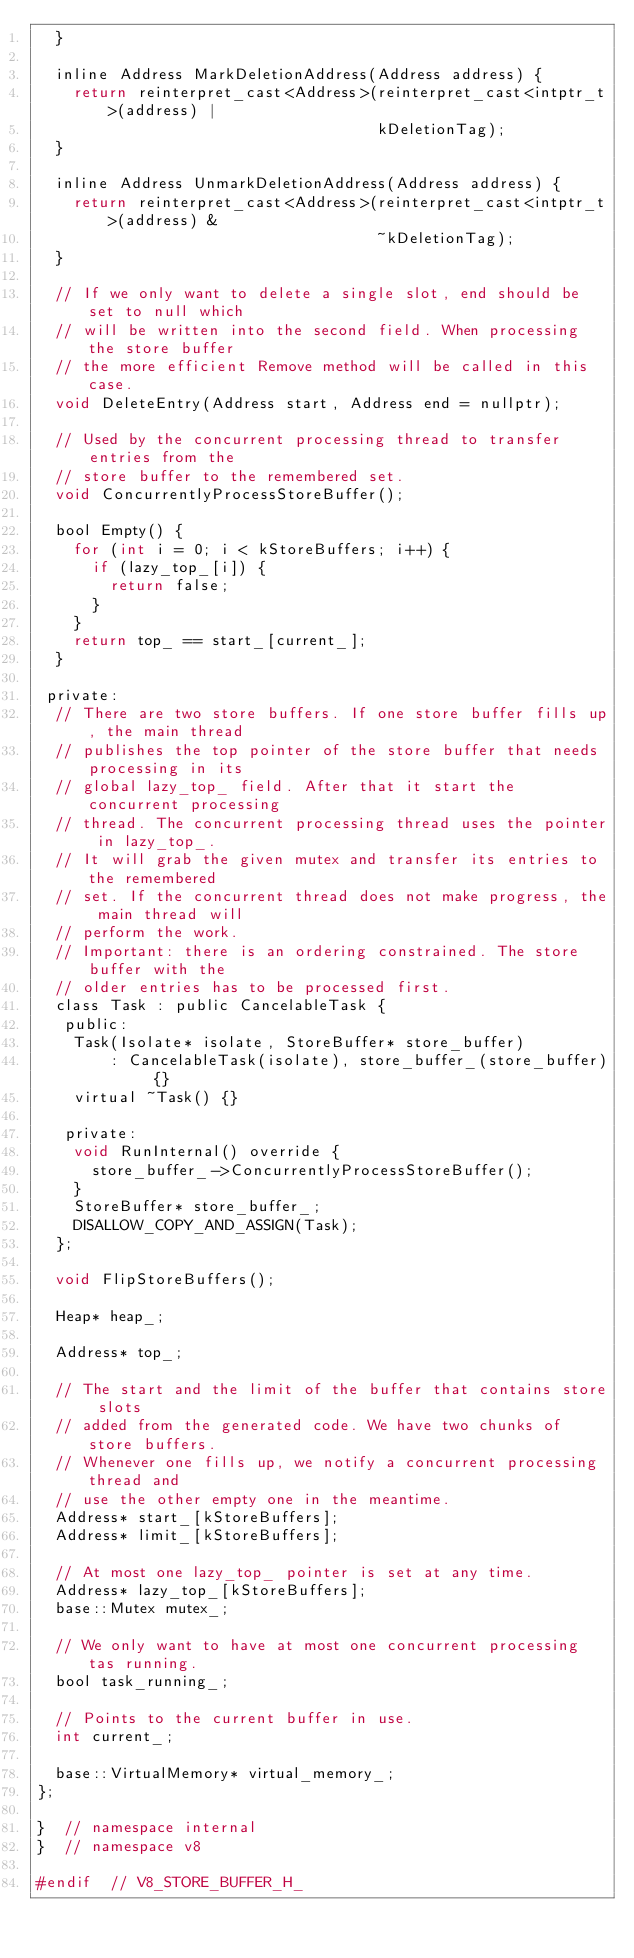<code> <loc_0><loc_0><loc_500><loc_500><_C_>  }

  inline Address MarkDeletionAddress(Address address) {
    return reinterpret_cast<Address>(reinterpret_cast<intptr_t>(address) |
                                     kDeletionTag);
  }

  inline Address UnmarkDeletionAddress(Address address) {
    return reinterpret_cast<Address>(reinterpret_cast<intptr_t>(address) &
                                     ~kDeletionTag);
  }

  // If we only want to delete a single slot, end should be set to null which
  // will be written into the second field. When processing the store buffer
  // the more efficient Remove method will be called in this case.
  void DeleteEntry(Address start, Address end = nullptr);

  // Used by the concurrent processing thread to transfer entries from the
  // store buffer to the remembered set.
  void ConcurrentlyProcessStoreBuffer();

  bool Empty() {
    for (int i = 0; i < kStoreBuffers; i++) {
      if (lazy_top_[i]) {
        return false;
      }
    }
    return top_ == start_[current_];
  }

 private:
  // There are two store buffers. If one store buffer fills up, the main thread
  // publishes the top pointer of the store buffer that needs processing in its
  // global lazy_top_ field. After that it start the concurrent processing
  // thread. The concurrent processing thread uses the pointer in lazy_top_.
  // It will grab the given mutex and transfer its entries to the remembered
  // set. If the concurrent thread does not make progress, the main thread will
  // perform the work.
  // Important: there is an ordering constrained. The store buffer with the
  // older entries has to be processed first.
  class Task : public CancelableTask {
   public:
    Task(Isolate* isolate, StoreBuffer* store_buffer)
        : CancelableTask(isolate), store_buffer_(store_buffer) {}
    virtual ~Task() {}

   private:
    void RunInternal() override {
      store_buffer_->ConcurrentlyProcessStoreBuffer();
    }
    StoreBuffer* store_buffer_;
    DISALLOW_COPY_AND_ASSIGN(Task);
  };

  void FlipStoreBuffers();

  Heap* heap_;

  Address* top_;

  // The start and the limit of the buffer that contains store slots
  // added from the generated code. We have two chunks of store buffers.
  // Whenever one fills up, we notify a concurrent processing thread and
  // use the other empty one in the meantime.
  Address* start_[kStoreBuffers];
  Address* limit_[kStoreBuffers];

  // At most one lazy_top_ pointer is set at any time.
  Address* lazy_top_[kStoreBuffers];
  base::Mutex mutex_;

  // We only want to have at most one concurrent processing tas running.
  bool task_running_;

  // Points to the current buffer in use.
  int current_;

  base::VirtualMemory* virtual_memory_;
};

}  // namespace internal
}  // namespace v8

#endif  // V8_STORE_BUFFER_H_
</code> 